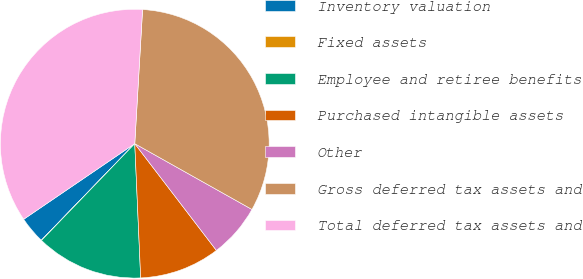Convert chart. <chart><loc_0><loc_0><loc_500><loc_500><pie_chart><fcel>Inventory valuation<fcel>Fixed assets<fcel>Employee and retiree benefits<fcel>Purchased intangible assets<fcel>Other<fcel>Gross deferred tax assets and<fcel>Total deferred tax assets and<nl><fcel>3.25%<fcel>0.03%<fcel>12.91%<fcel>9.69%<fcel>6.47%<fcel>32.22%<fcel>35.44%<nl></chart> 